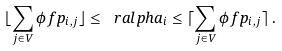Convert formula to latex. <formula><loc_0><loc_0><loc_500><loc_500>\lfloor \sum _ { j \in V } \phi f p _ { i , j } \rfloor \leq \ r a l p h a _ { i } \leq \lceil \sum _ { j \in V } \phi f p _ { i , j } \rceil \, .</formula> 